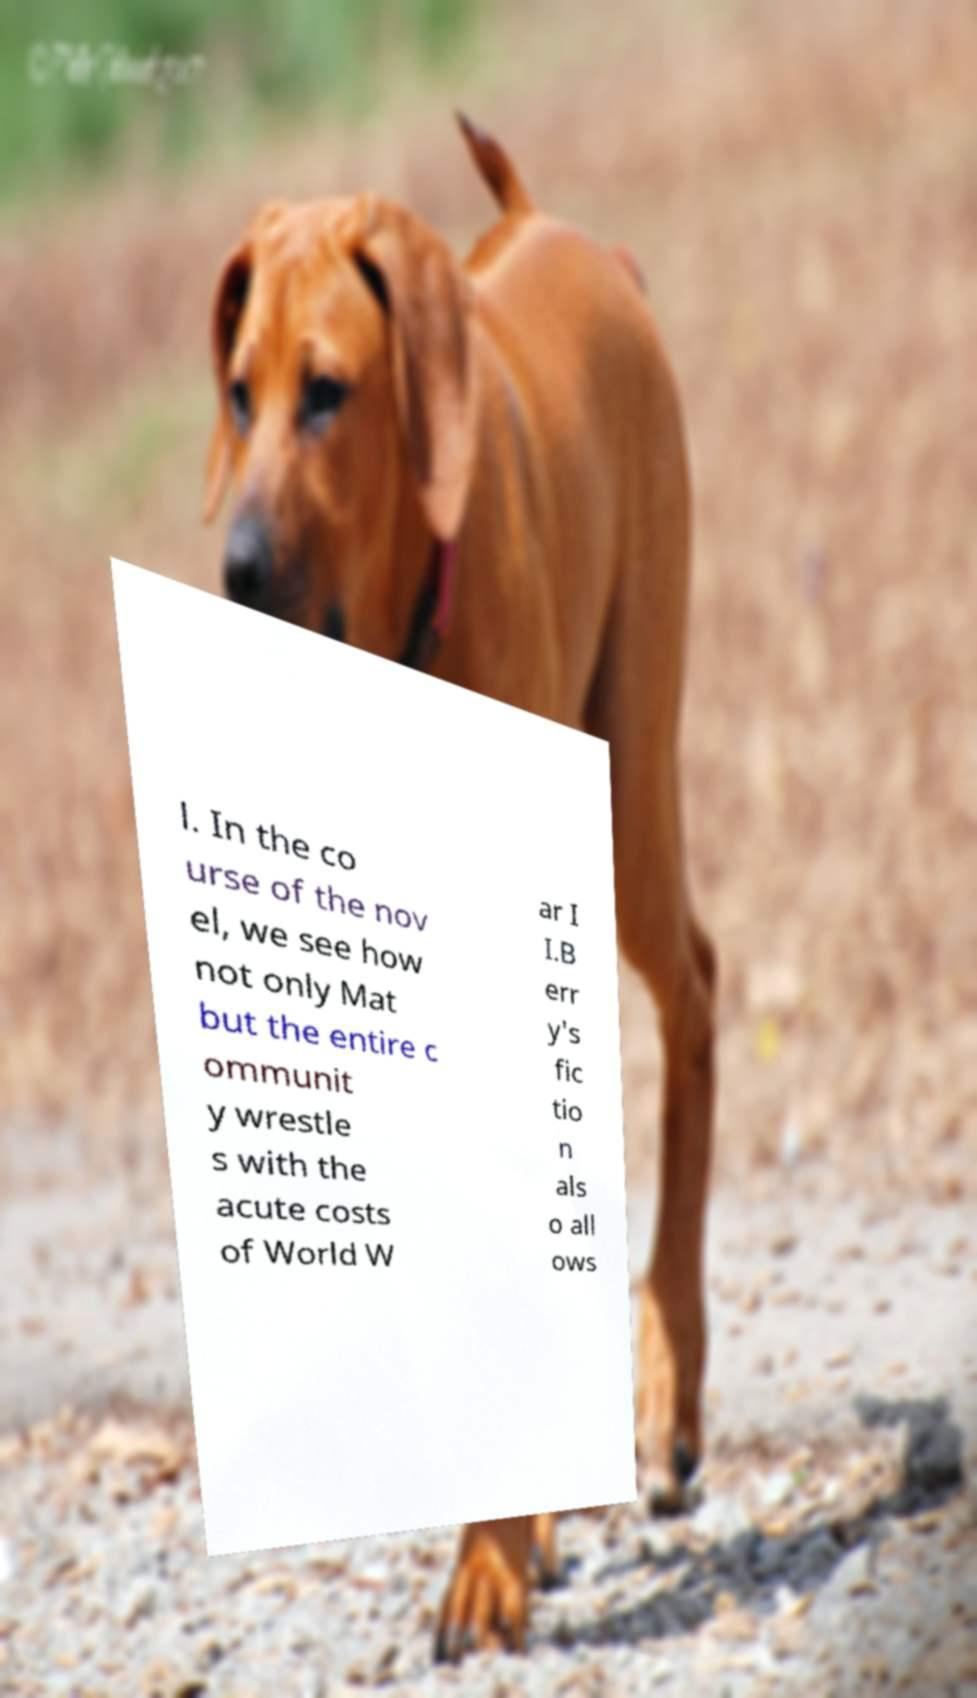I need the written content from this picture converted into text. Can you do that? l. In the co urse of the nov el, we see how not only Mat but the entire c ommunit y wrestle s with the acute costs of World W ar I I.B err y's fic tio n als o all ows 